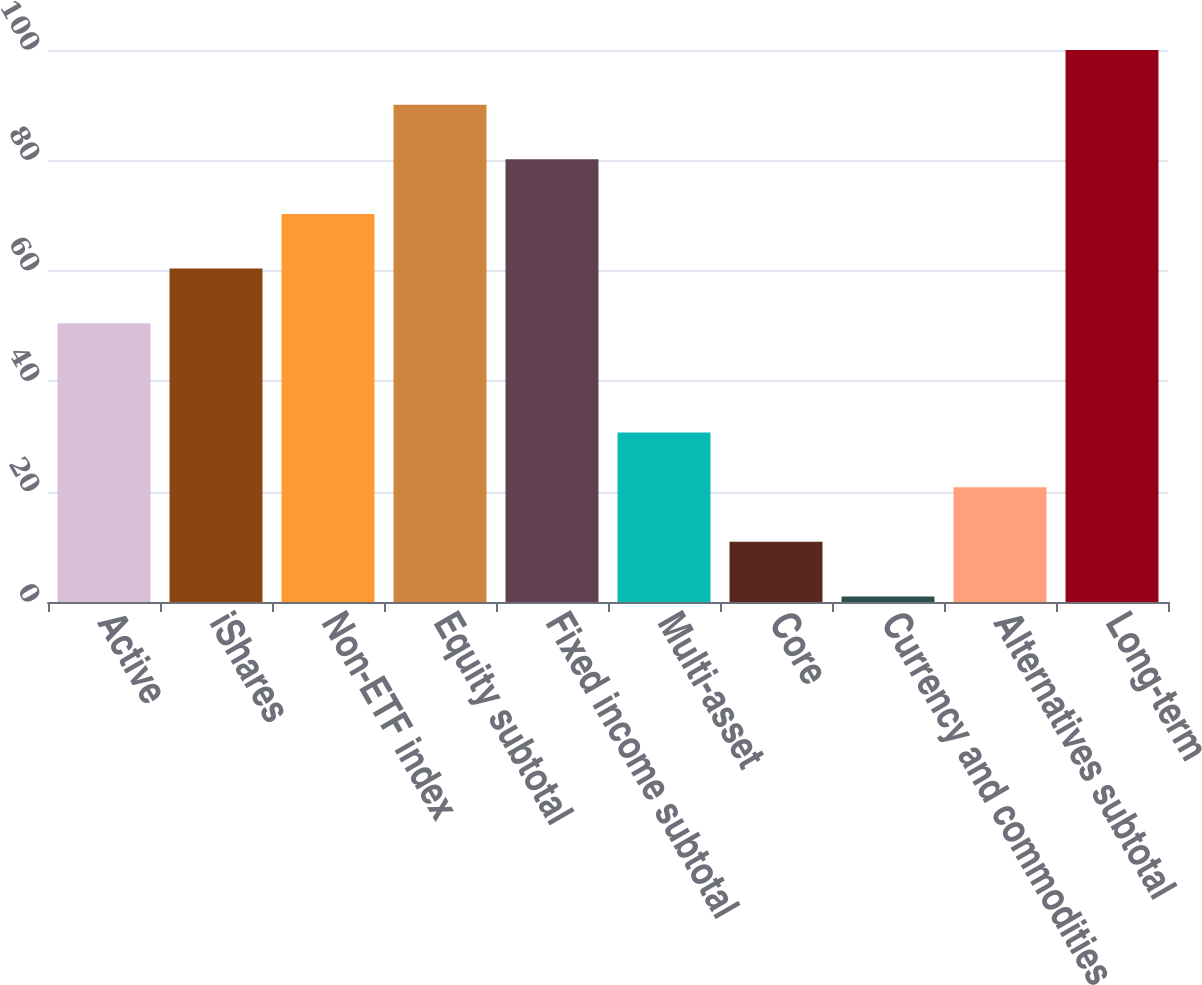Convert chart. <chart><loc_0><loc_0><loc_500><loc_500><bar_chart><fcel>Active<fcel>iShares<fcel>Non-ETF index<fcel>Equity subtotal<fcel>Fixed income subtotal<fcel>Multi-asset<fcel>Core<fcel>Currency and commodities<fcel>Alternatives subtotal<fcel>Long-term<nl><fcel>50.5<fcel>60.4<fcel>70.3<fcel>90.1<fcel>80.2<fcel>30.7<fcel>10.9<fcel>1<fcel>20.8<fcel>100<nl></chart> 